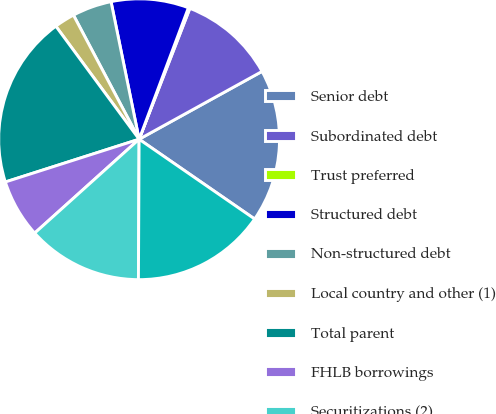Convert chart to OTSL. <chart><loc_0><loc_0><loc_500><loc_500><pie_chart><fcel>Senior debt<fcel>Subordinated debt<fcel>Trust preferred<fcel>Structured debt<fcel>Non-structured debt<fcel>Local country and other (1)<fcel>Total parent<fcel>FHLB borrowings<fcel>Securitizations (2)<fcel>Total bank<nl><fcel>17.64%<fcel>11.09%<fcel>0.18%<fcel>8.91%<fcel>4.54%<fcel>2.36%<fcel>19.82%<fcel>6.73%<fcel>13.27%<fcel>15.46%<nl></chart> 